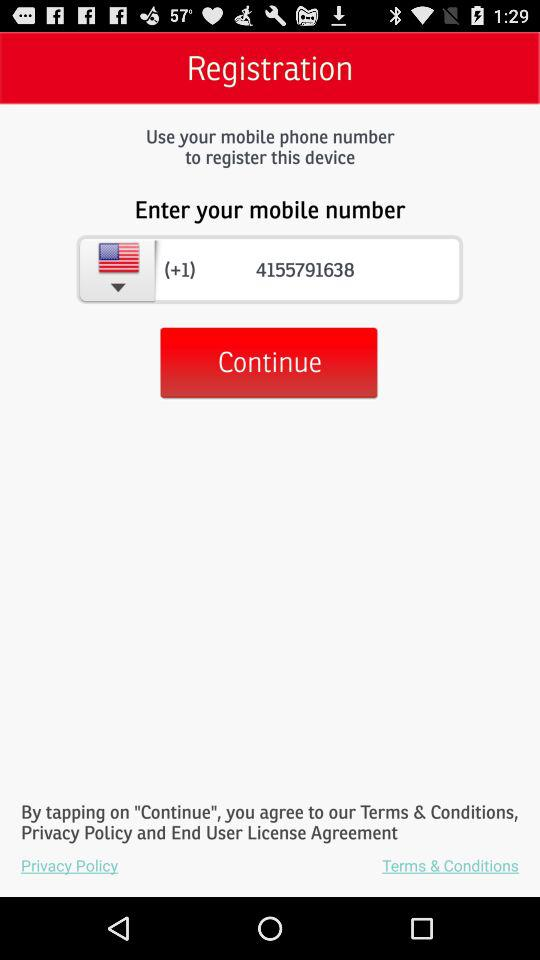What steps are mentioned for registering the device? The image shows a screen for device registration, where the first step is to enter a mobile number. Users must then tap the 'Continue' button to proceed with the registration process. 